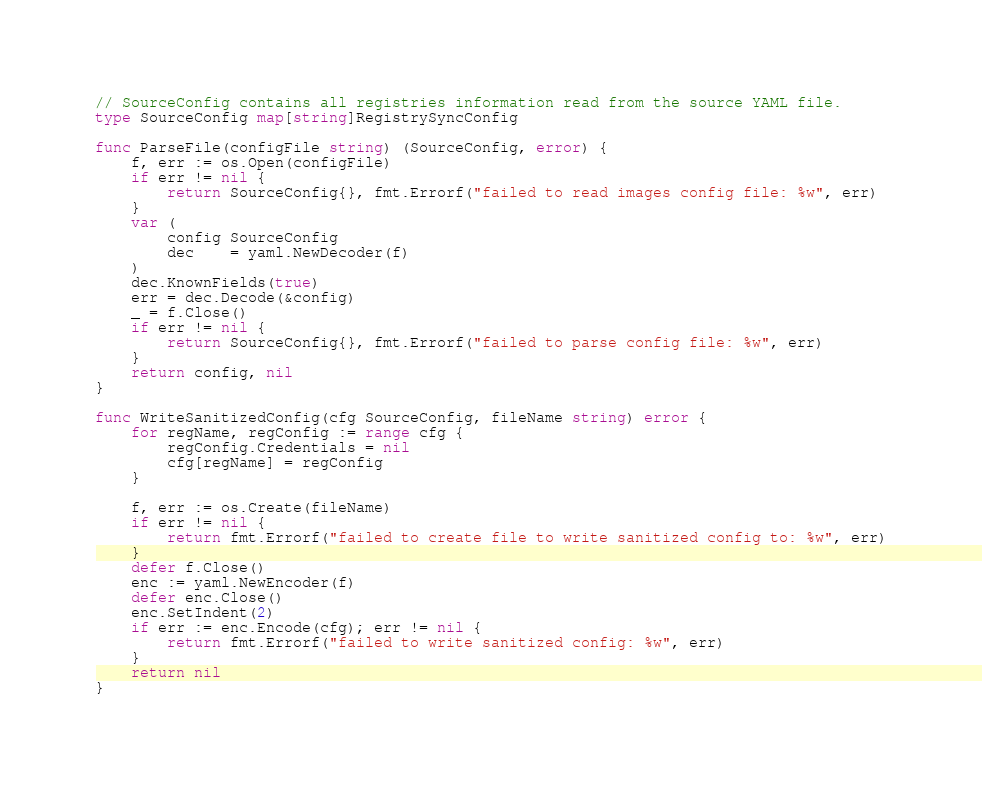Convert code to text. <code><loc_0><loc_0><loc_500><loc_500><_Go_>// SourceConfig contains all registries information read from the source YAML file.
type SourceConfig map[string]RegistrySyncConfig

func ParseFile(configFile string) (SourceConfig, error) {
	f, err := os.Open(configFile)
	if err != nil {
		return SourceConfig{}, fmt.Errorf("failed to read images config file: %w", err)
	}
	var (
		config SourceConfig
		dec    = yaml.NewDecoder(f)
	)
	dec.KnownFields(true)
	err = dec.Decode(&config)
	_ = f.Close()
	if err != nil {
		return SourceConfig{}, fmt.Errorf("failed to parse config file: %w", err)
	}
	return config, nil
}

func WriteSanitizedConfig(cfg SourceConfig, fileName string) error {
	for regName, regConfig := range cfg {
		regConfig.Credentials = nil
		cfg[regName] = regConfig
	}

	f, err := os.Create(fileName)
	if err != nil {
		return fmt.Errorf("failed to create file to write sanitized config to: %w", err)
	}
	defer f.Close()
	enc := yaml.NewEncoder(f)
	defer enc.Close()
	enc.SetIndent(2)
	if err := enc.Encode(cfg); err != nil {
		return fmt.Errorf("failed to write sanitized config: %w", err)
	}
	return nil
}
</code> 